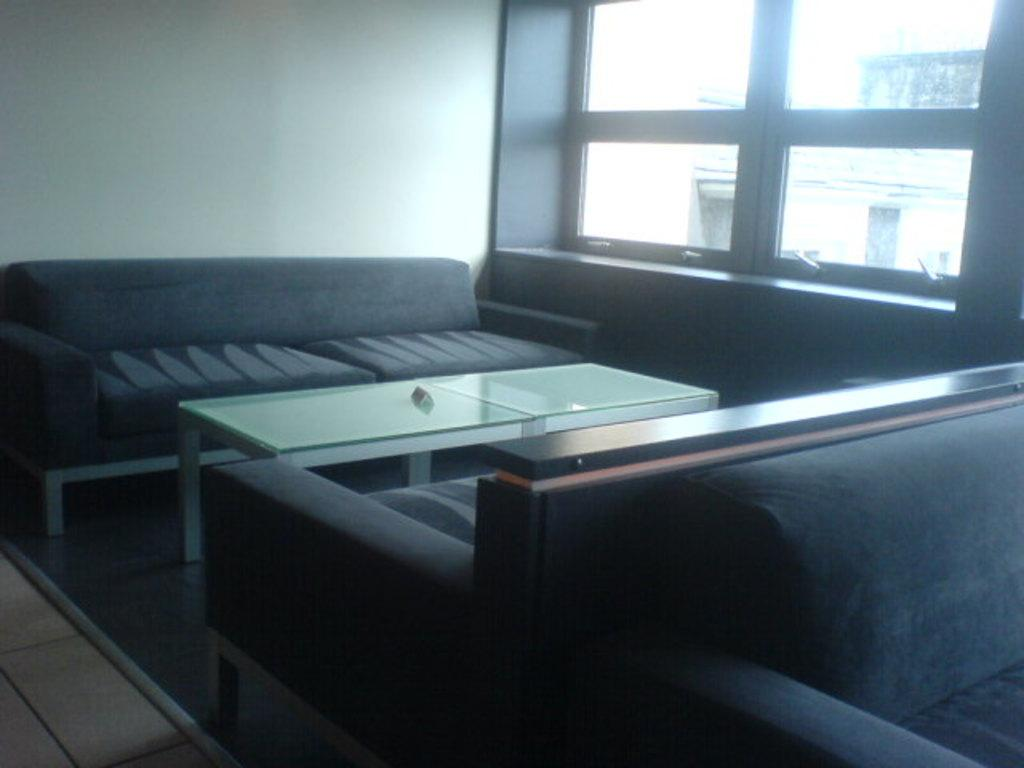Where was the image taken? The image was taken inside a room. What is the main piece of furniture in the room? There is a table in the middle of the room. What type of seating is available in the room? There are sofas in the room. What can be seen in the background of the image? There is a window, glass, and a wall in the background. What type of behavior is the potato exhibiting in the image? There is no potato present in the image, so it cannot exhibit any behavior. 